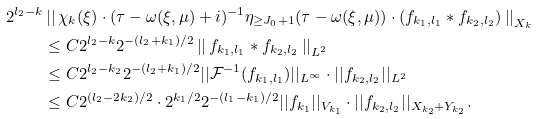Convert formula to latex. <formula><loc_0><loc_0><loc_500><loc_500>2 ^ { l _ { 2 } - k } & \left | \right | \chi _ { k } ( \xi ) \cdot ( \tau - \omega ( \xi , \mu ) + i ) ^ { - 1 } \eta _ { \geq J _ { 0 } + 1 } ( \tau - \omega ( \xi , \mu ) ) \cdot ( f _ { k _ { 1 } , l _ { 1 } } \ast f _ { k _ { 2 } , l _ { 2 } } ) \left | \right | _ { X _ { k } } \\ & \leq C 2 ^ { l _ { 2 } - k } 2 ^ { - ( l _ { 2 } + k _ { 1 } ) / 2 } \left | \right | f _ { k _ { 1 } , l _ { 1 } } \ast f _ { k _ { 2 } , l _ { 2 } } \left | \right | _ { L ^ { 2 } } \\ & \leq C 2 ^ { l _ { 2 } - k _ { 2 } } 2 ^ { - ( l _ { 2 } + k _ { 1 } ) / 2 } | | \mathcal { F } ^ { - 1 } ( f _ { k _ { 1 } , l _ { 1 } } ) | | _ { L ^ { \infty } } \cdot | | f _ { k _ { 2 } , l _ { 2 } } | | _ { L ^ { 2 } } \\ & \leq C 2 ^ { ( l _ { 2 } - 2 k _ { 2 } ) / 2 } \cdot 2 ^ { k _ { 1 } / 2 } 2 ^ { - ( l _ { 1 } - k _ { 1 } ) / 2 } | | f _ { k _ { 1 } } | | _ { V _ { k _ { 1 } } } \cdot | | f _ { k _ { 2 } , l _ { 2 } } | | _ { X _ { k _ { 2 } } + Y _ { k _ { 2 } } } .</formula> 